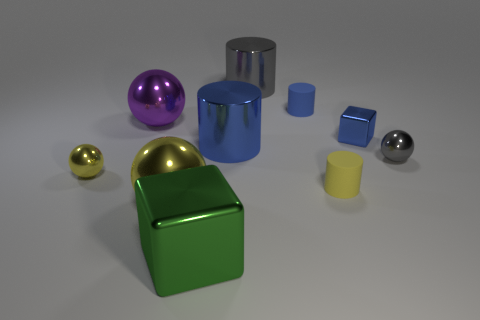How many other blue metal things are the same shape as the large blue thing? In the image, there is only one large blue cylindrical object and no other blue objects share the same cylindrical shape. 